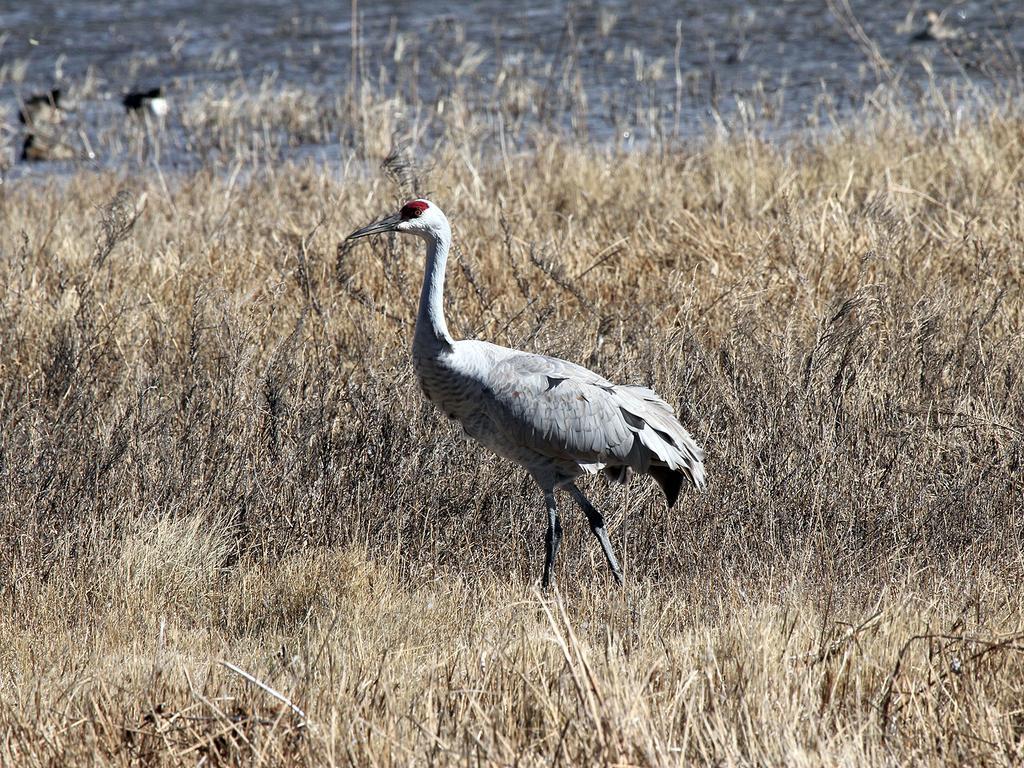Describe this image in one or two sentences. In this picture we can see grass and a bird, in the background we can see water. 